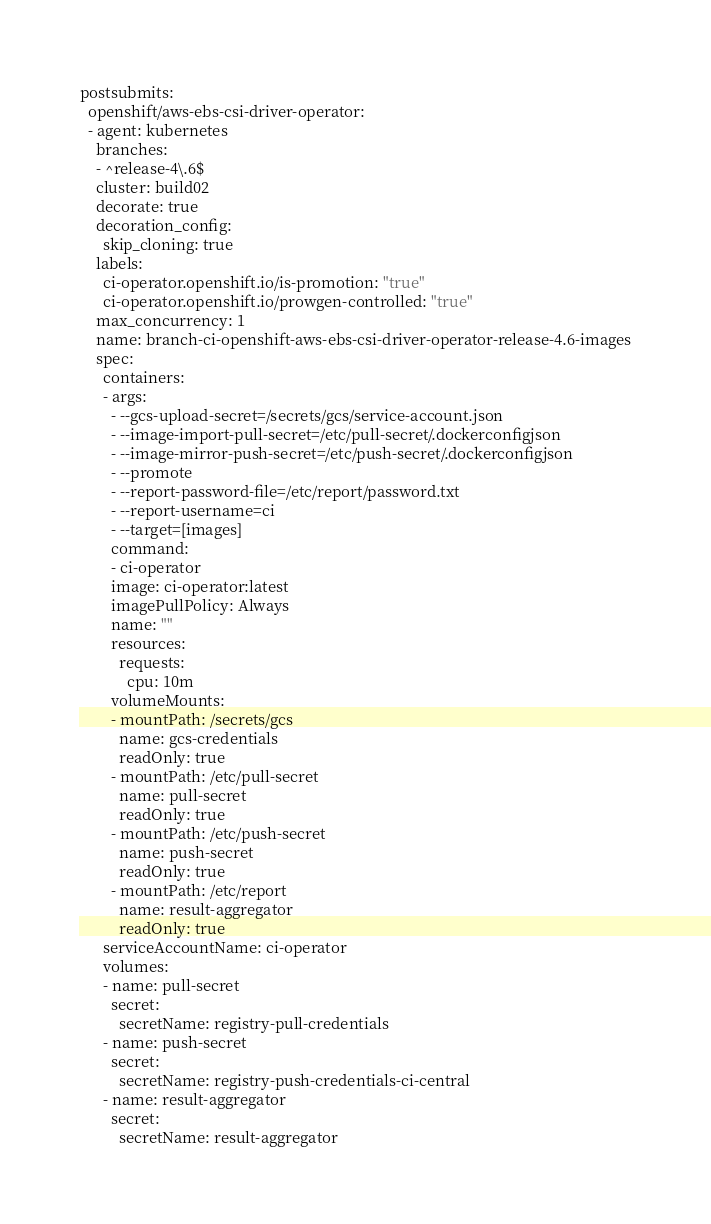<code> <loc_0><loc_0><loc_500><loc_500><_YAML_>postsubmits:
  openshift/aws-ebs-csi-driver-operator:
  - agent: kubernetes
    branches:
    - ^release-4\.6$
    cluster: build02
    decorate: true
    decoration_config:
      skip_cloning: true
    labels:
      ci-operator.openshift.io/is-promotion: "true"
      ci-operator.openshift.io/prowgen-controlled: "true"
    max_concurrency: 1
    name: branch-ci-openshift-aws-ebs-csi-driver-operator-release-4.6-images
    spec:
      containers:
      - args:
        - --gcs-upload-secret=/secrets/gcs/service-account.json
        - --image-import-pull-secret=/etc/pull-secret/.dockerconfigjson
        - --image-mirror-push-secret=/etc/push-secret/.dockerconfigjson
        - --promote
        - --report-password-file=/etc/report/password.txt
        - --report-username=ci
        - --target=[images]
        command:
        - ci-operator
        image: ci-operator:latest
        imagePullPolicy: Always
        name: ""
        resources:
          requests:
            cpu: 10m
        volumeMounts:
        - mountPath: /secrets/gcs
          name: gcs-credentials
          readOnly: true
        - mountPath: /etc/pull-secret
          name: pull-secret
          readOnly: true
        - mountPath: /etc/push-secret
          name: push-secret
          readOnly: true
        - mountPath: /etc/report
          name: result-aggregator
          readOnly: true
      serviceAccountName: ci-operator
      volumes:
      - name: pull-secret
        secret:
          secretName: registry-pull-credentials
      - name: push-secret
        secret:
          secretName: registry-push-credentials-ci-central
      - name: result-aggregator
        secret:
          secretName: result-aggregator
</code> 